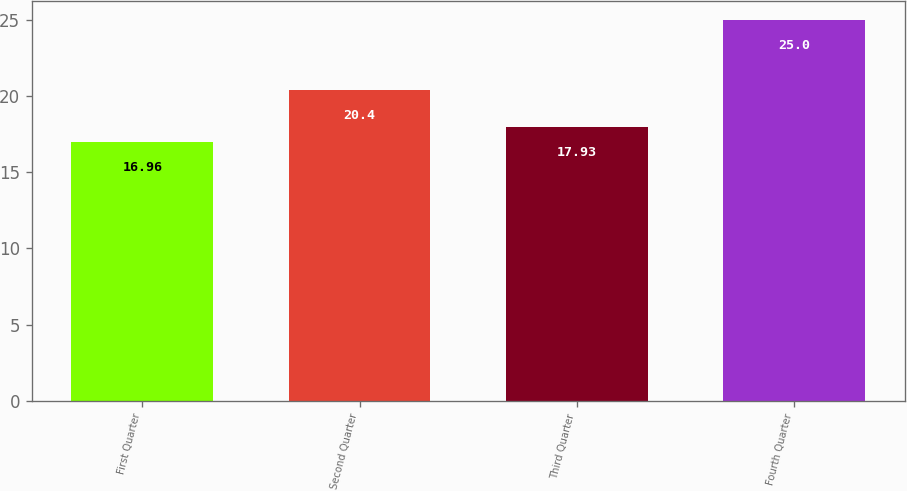Convert chart to OTSL. <chart><loc_0><loc_0><loc_500><loc_500><bar_chart><fcel>First Quarter<fcel>Second Quarter<fcel>Third Quarter<fcel>Fourth Quarter<nl><fcel>16.96<fcel>20.4<fcel>17.93<fcel>25<nl></chart> 